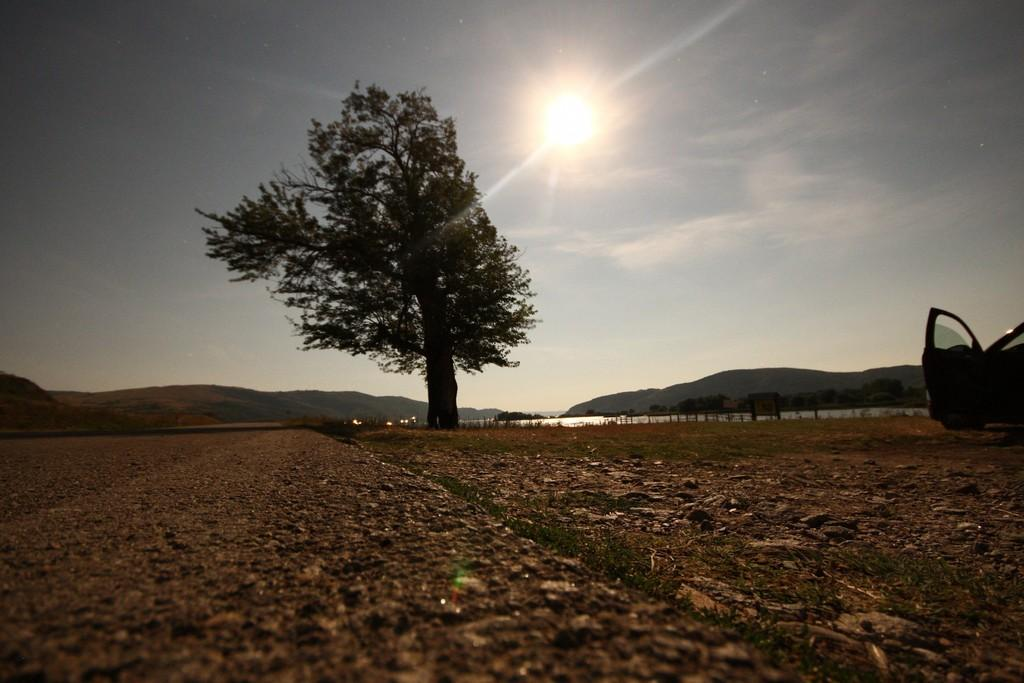What is the main subject of the image? There is a vehicle on a path in the image. What can be seen on the left side of the vehicle? There is a tree on the left side of the vehicle. What is visible behind the tree? There is water visible behind the tree. What can be seen in the background of the image? There are hills in the background of the image. What is the condition of the sky in the image? The sun is visible in the sky. Where is the horse show taking place in the image? There is no horse show present in the image; it features a vehicle on a path with a tree, water, hills, and the sun visible in the sky. 